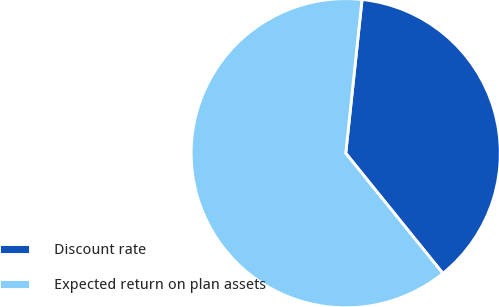Convert chart to OTSL. <chart><loc_0><loc_0><loc_500><loc_500><pie_chart><fcel>Discount rate<fcel>Expected return on plan assets<nl><fcel>37.5%<fcel>62.5%<nl></chart> 